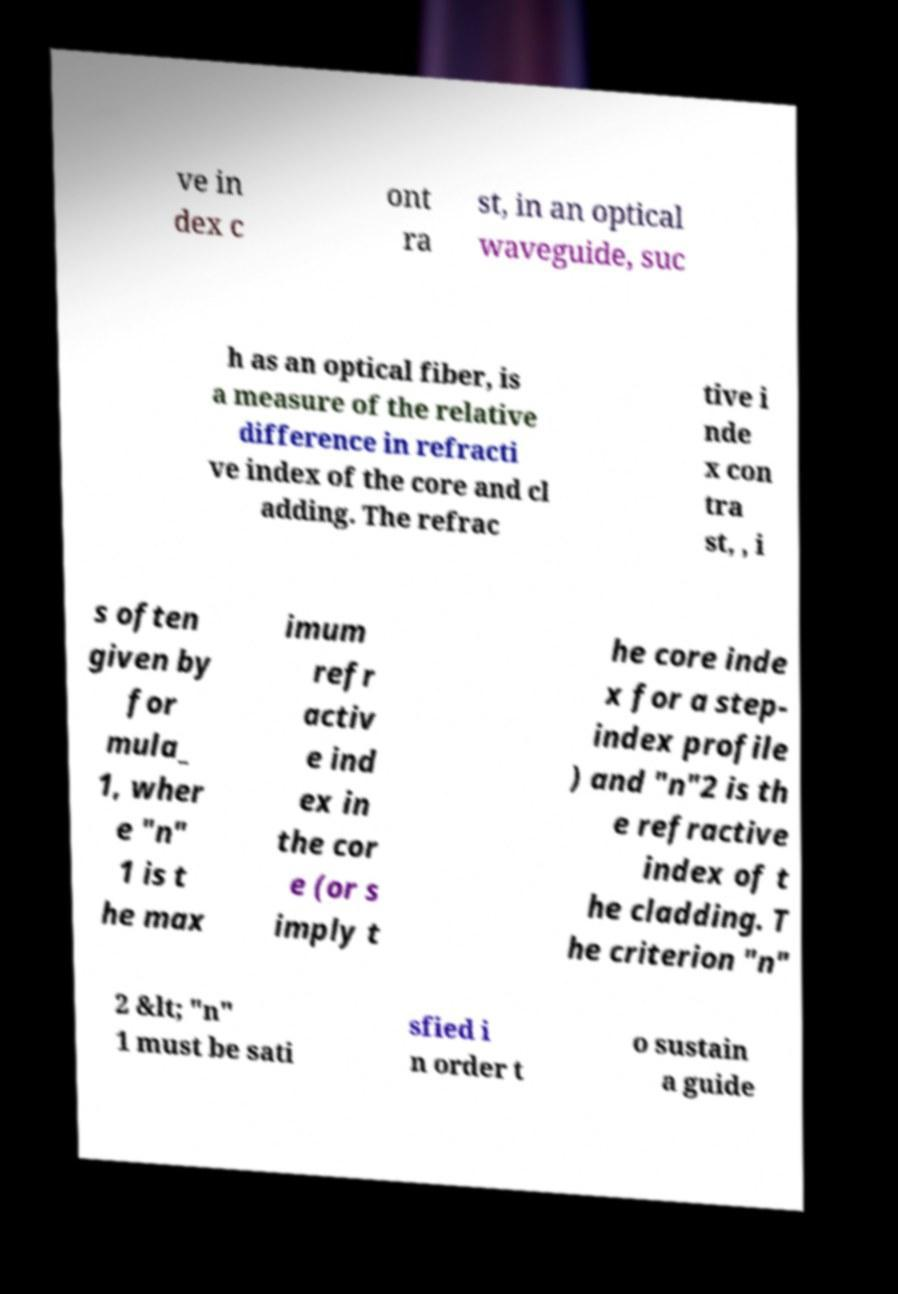Can you read and provide the text displayed in the image?This photo seems to have some interesting text. Can you extract and type it out for me? ve in dex c ont ra st, in an optical waveguide, suc h as an optical fiber, is a measure of the relative difference in refracti ve index of the core and cl adding. The refrac tive i nde x con tra st, , i s often given by for mula_ 1, wher e "n" 1 is t he max imum refr activ e ind ex in the cor e (or s imply t he core inde x for a step- index profile ) and "n"2 is th e refractive index of t he cladding. T he criterion "n" 2 &lt; "n" 1 must be sati sfied i n order t o sustain a guide 